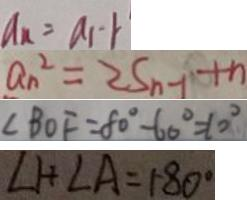<formula> <loc_0><loc_0><loc_500><loc_500>a _ { n } = a _ { 1 } - 1 
 a _ { n } ^ { 2 } = 2 S _ { n - 1 } + n 
 \angle B O F = 8 0 ^ { \circ } - 6 0 ^ { \circ } = 1 0 ^ { \circ } 
 \angle 1 + \angle A = 1 8 0 ^ { \circ }</formula> 